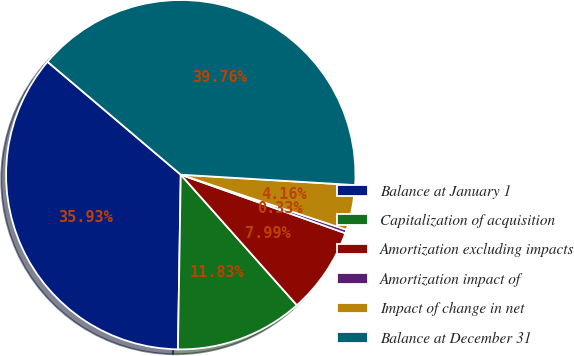Convert chart to OTSL. <chart><loc_0><loc_0><loc_500><loc_500><pie_chart><fcel>Balance at January 1<fcel>Capitalization of acquisition<fcel>Amortization excluding impacts<fcel>Amortization impact of<fcel>Impact of change in net<fcel>Balance at December 31<nl><fcel>35.93%<fcel>11.83%<fcel>7.99%<fcel>0.33%<fcel>4.16%<fcel>39.76%<nl></chart> 